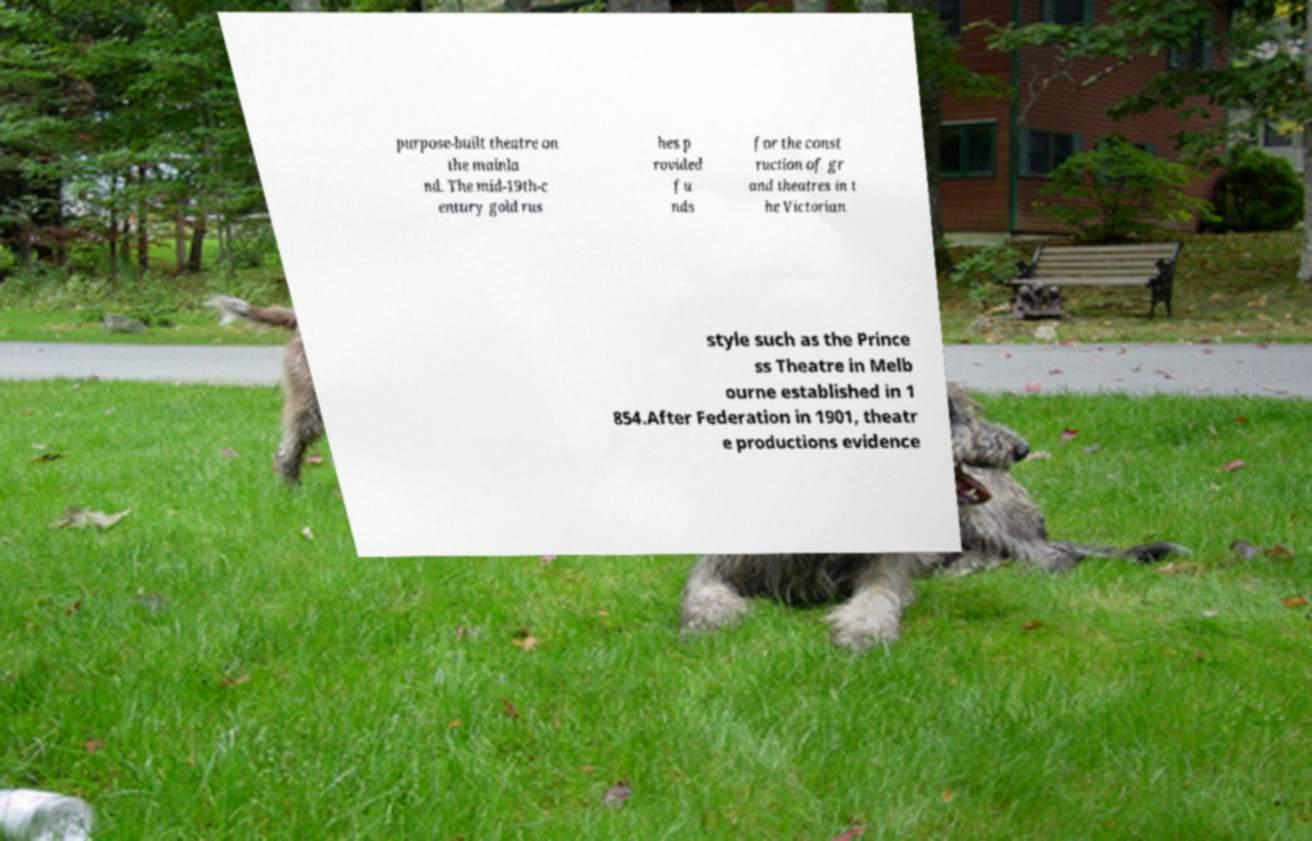For documentation purposes, I need the text within this image transcribed. Could you provide that? purpose-built theatre on the mainla nd. The mid-19th-c entury gold rus hes p rovided fu nds for the const ruction of gr and theatres in t he Victorian style such as the Prince ss Theatre in Melb ourne established in 1 854.After Federation in 1901, theatr e productions evidence 